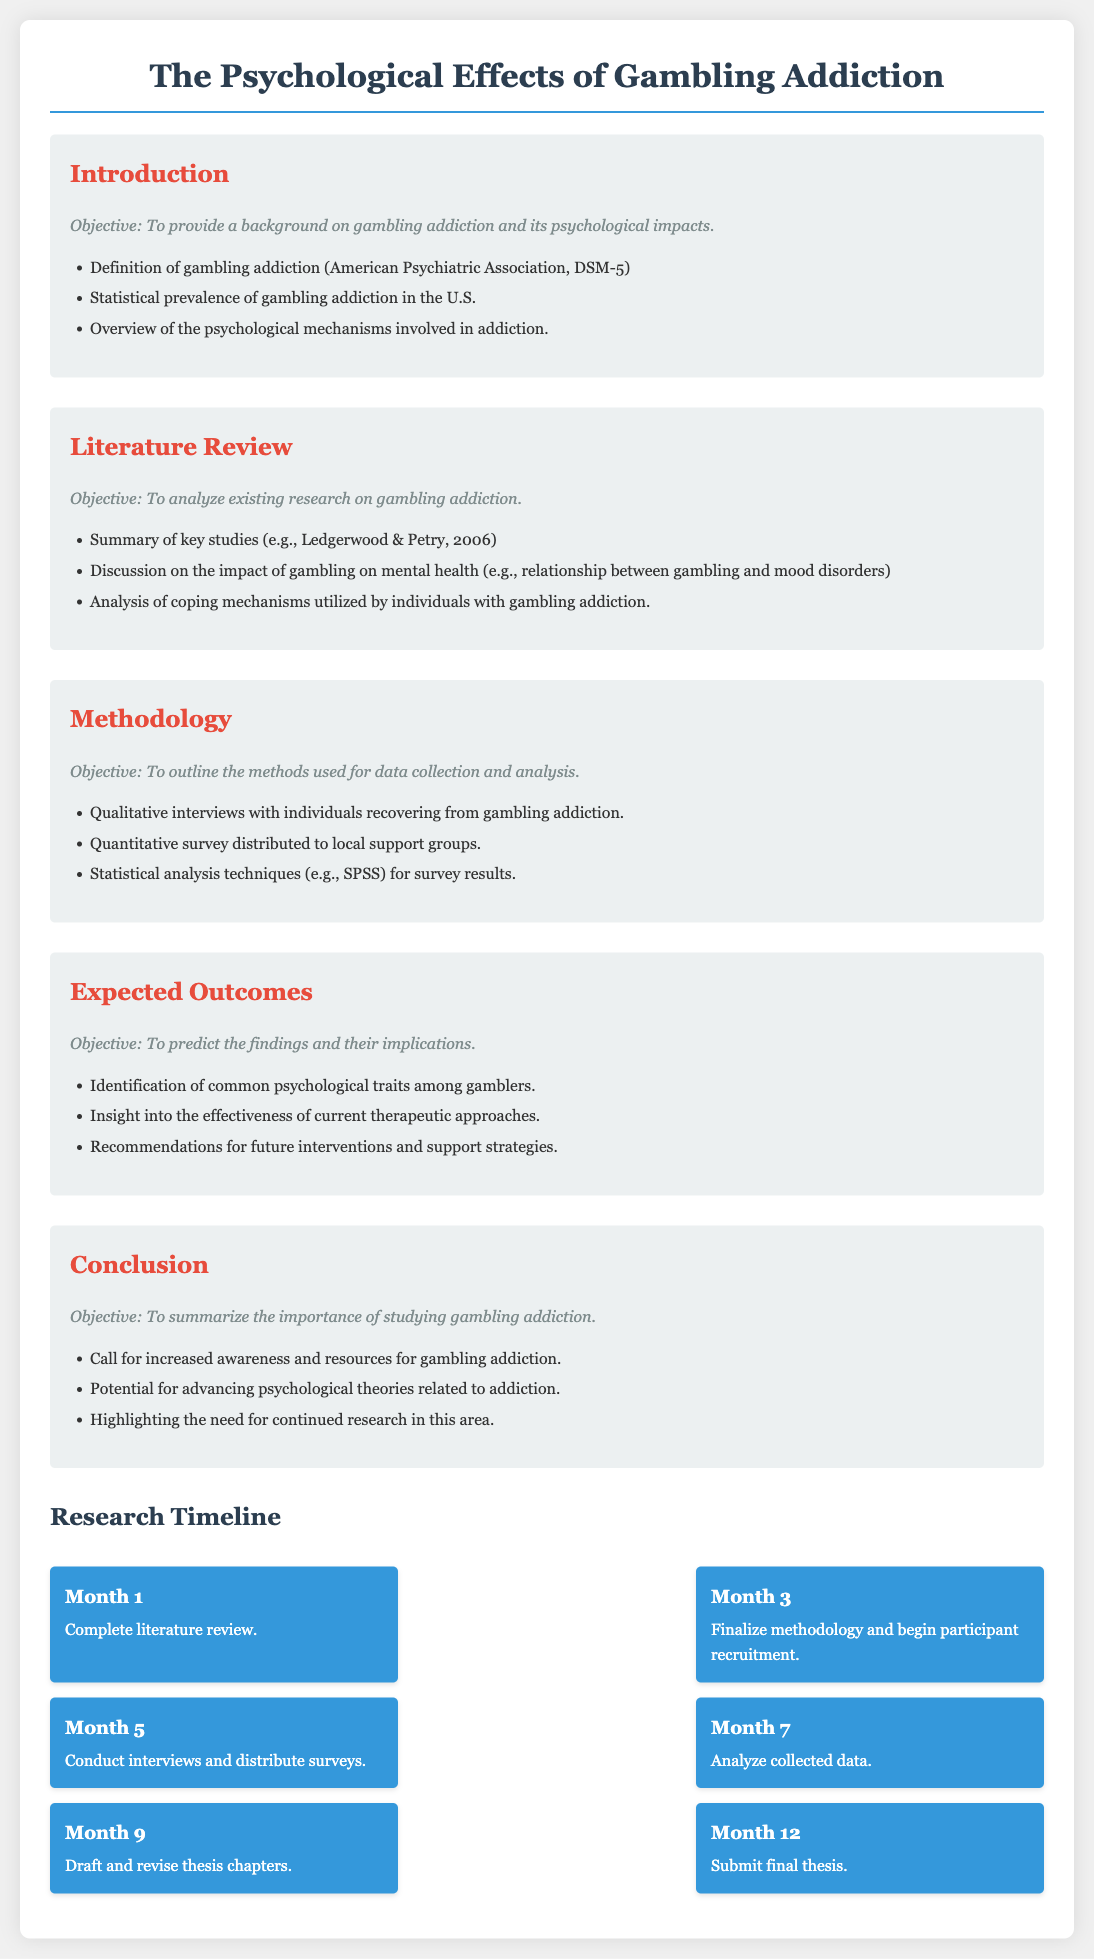What is the primary objective of the thesis? The primary objective is detailed in the introduction section, which explains the aim of providing a background on gambling addiction and its psychological impacts.
Answer: To provide a background on gambling addiction and its psychological impacts Who are the authors cited in the literature review? The literature review mentions key studies and one specific example is provided, which identifies the authors.
Answer: Ledgerwood & Petry What data collection method involves talking to individuals? The methodology section outlines various methods of data collection, including one which specifically involves personal interactions with participants.
Answer: Qualitative interviews What statistical software is mentioned for data analysis? The methodology section specifies which software will be used to analyze the survey results.
Answer: SPSS How many months are allocated for drafting and revising thesis chapters? The timeline informs about the specific duration set for this phase of the research.
Answer: 2 months What is the conclusion's main call to action? The conclusion section summarizes a significant need highlighted in the thesis regarding gambling addiction awareness.
Answer: Increased awareness and resources Which month marks the completion of the literature review? The timeline presents the milestones for the research and indicates when the literature review is due for completion.
Answer: Month 1 What is the primary research focus of the thesis? The thesis proposal centers around a specific psychological issue, as stated in the title and introduction.
Answer: Gambling addiction 